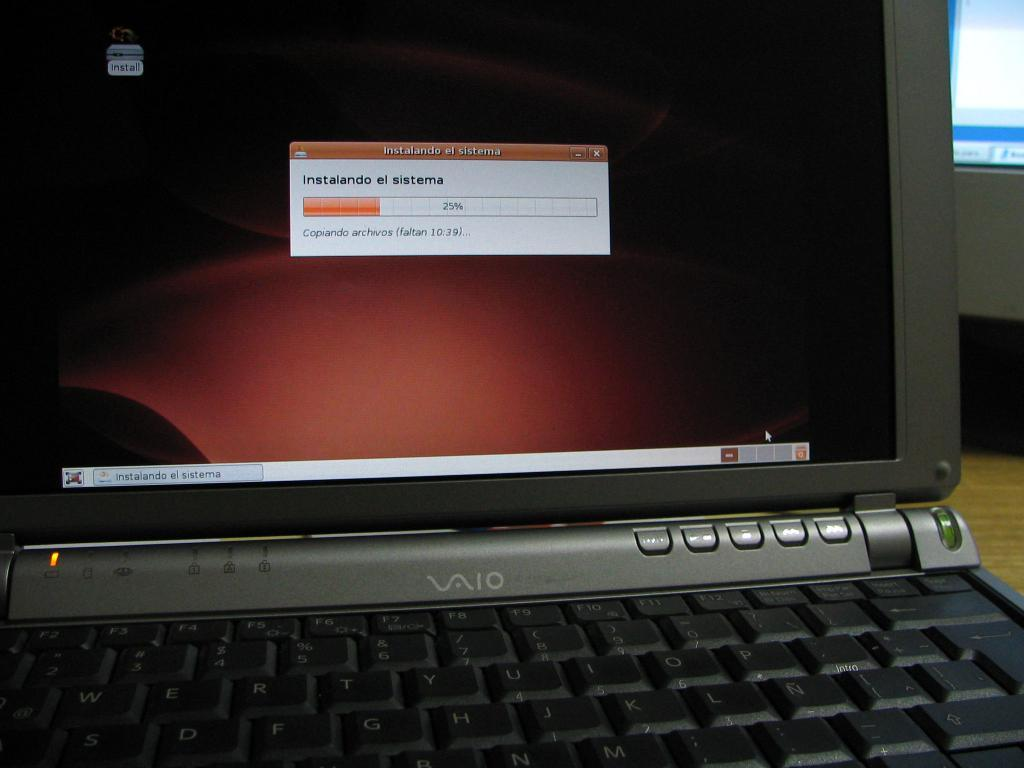Provide a one-sentence caption for the provided image. A VAIO laptop displaying a downloading message on the screen. 